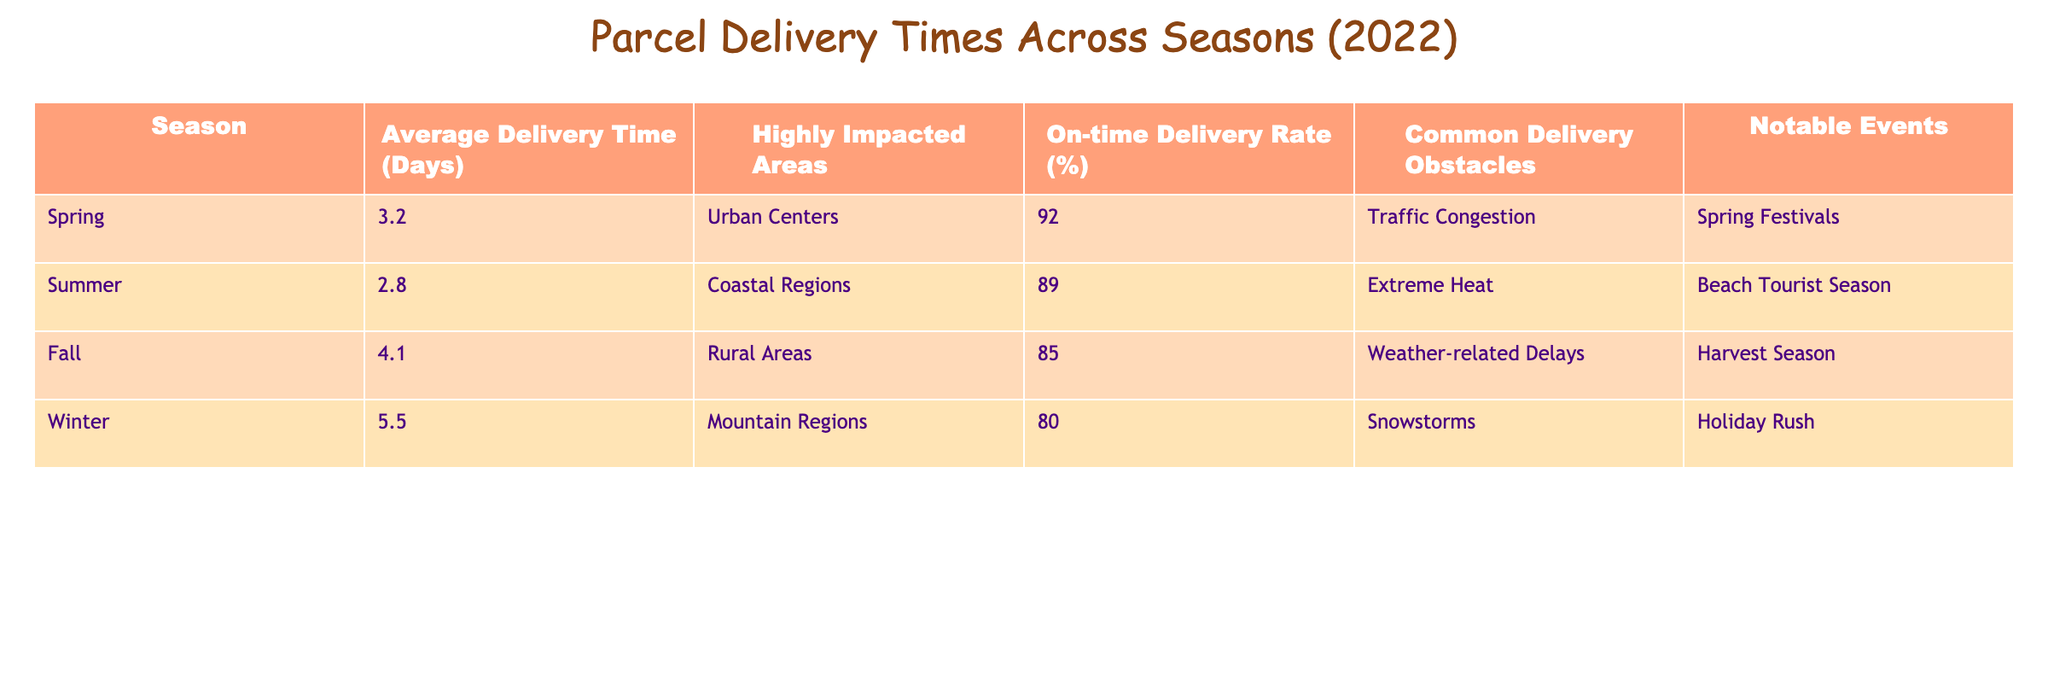What is the average delivery time in Winter? The table indicates the average delivery time in Winter is listed under that season, which is 5.5 days.
Answer: 5.5 days Which season has the highest on-time delivery rate? Looking at the table, the on-time delivery rate is highest in Spring at 92%.
Answer: Spring What are the common delivery obstacles in Fall? The table shows that the common delivery obstacles in Fall are weather-related delays.
Answer: Weather-related delays How do the average delivery times in Spring and Summer compare? The average delivery time in Spring is 3.2 days, while in Summer it's 2.8 days. Thus, Spring's delivery time is longer by 0.4 days.
Answer: Spring's is 0.4 days longer Is the on-time delivery rate in Rural Areas higher than in Coastal Regions? The table indicates an on-time delivery rate of 85% in Rural Areas and 89% in Coastal Regions, so it is not higher.
Answer: No What is the difference in average delivery time between Winter and Summer? The average delivery time in Winter is 5.5 days, and in Summer it is 2.8 days. The difference is 5.5 - 2.8 = 2.7 days.
Answer: 2.7 days Which season has the lowest on-time delivery rate? According to the table, Winter has the lowest on-time delivery rate at 80%.
Answer: Winter If you combine the average delivery times of Spring and Fall, what is the total? The average delivery time for Spring is 3.2 days and for Fall is 4.1 days. Summing these gives 3.2 + 4.1 = 7.3 days.
Answer: 7.3 days Is the average delivery time in Summer less than the overall average of the four seasons? The average delivery time in Summer is 2.8 days. To find the overall average: (3.2 + 2.8 + 4.1 + 5.5) / 4 = 3.9 days. Since 2.8 < 3.9, the statement is true.
Answer: Yes What notable event occurs during the holiday season that impacts delivery? The table notes that during Winter, the notable event that impacts delivery is the holiday rush.
Answer: Holiday rush What is the on-time delivery rate for Urban Centers compared to Mountain Regions? The on-time delivery rate for Urban Centers is 92% (Spring) and for Mountain Regions is 80% (Winter). Thus, Urban Centers have a higher delivery rate.
Answer: Urban Centers are higher 